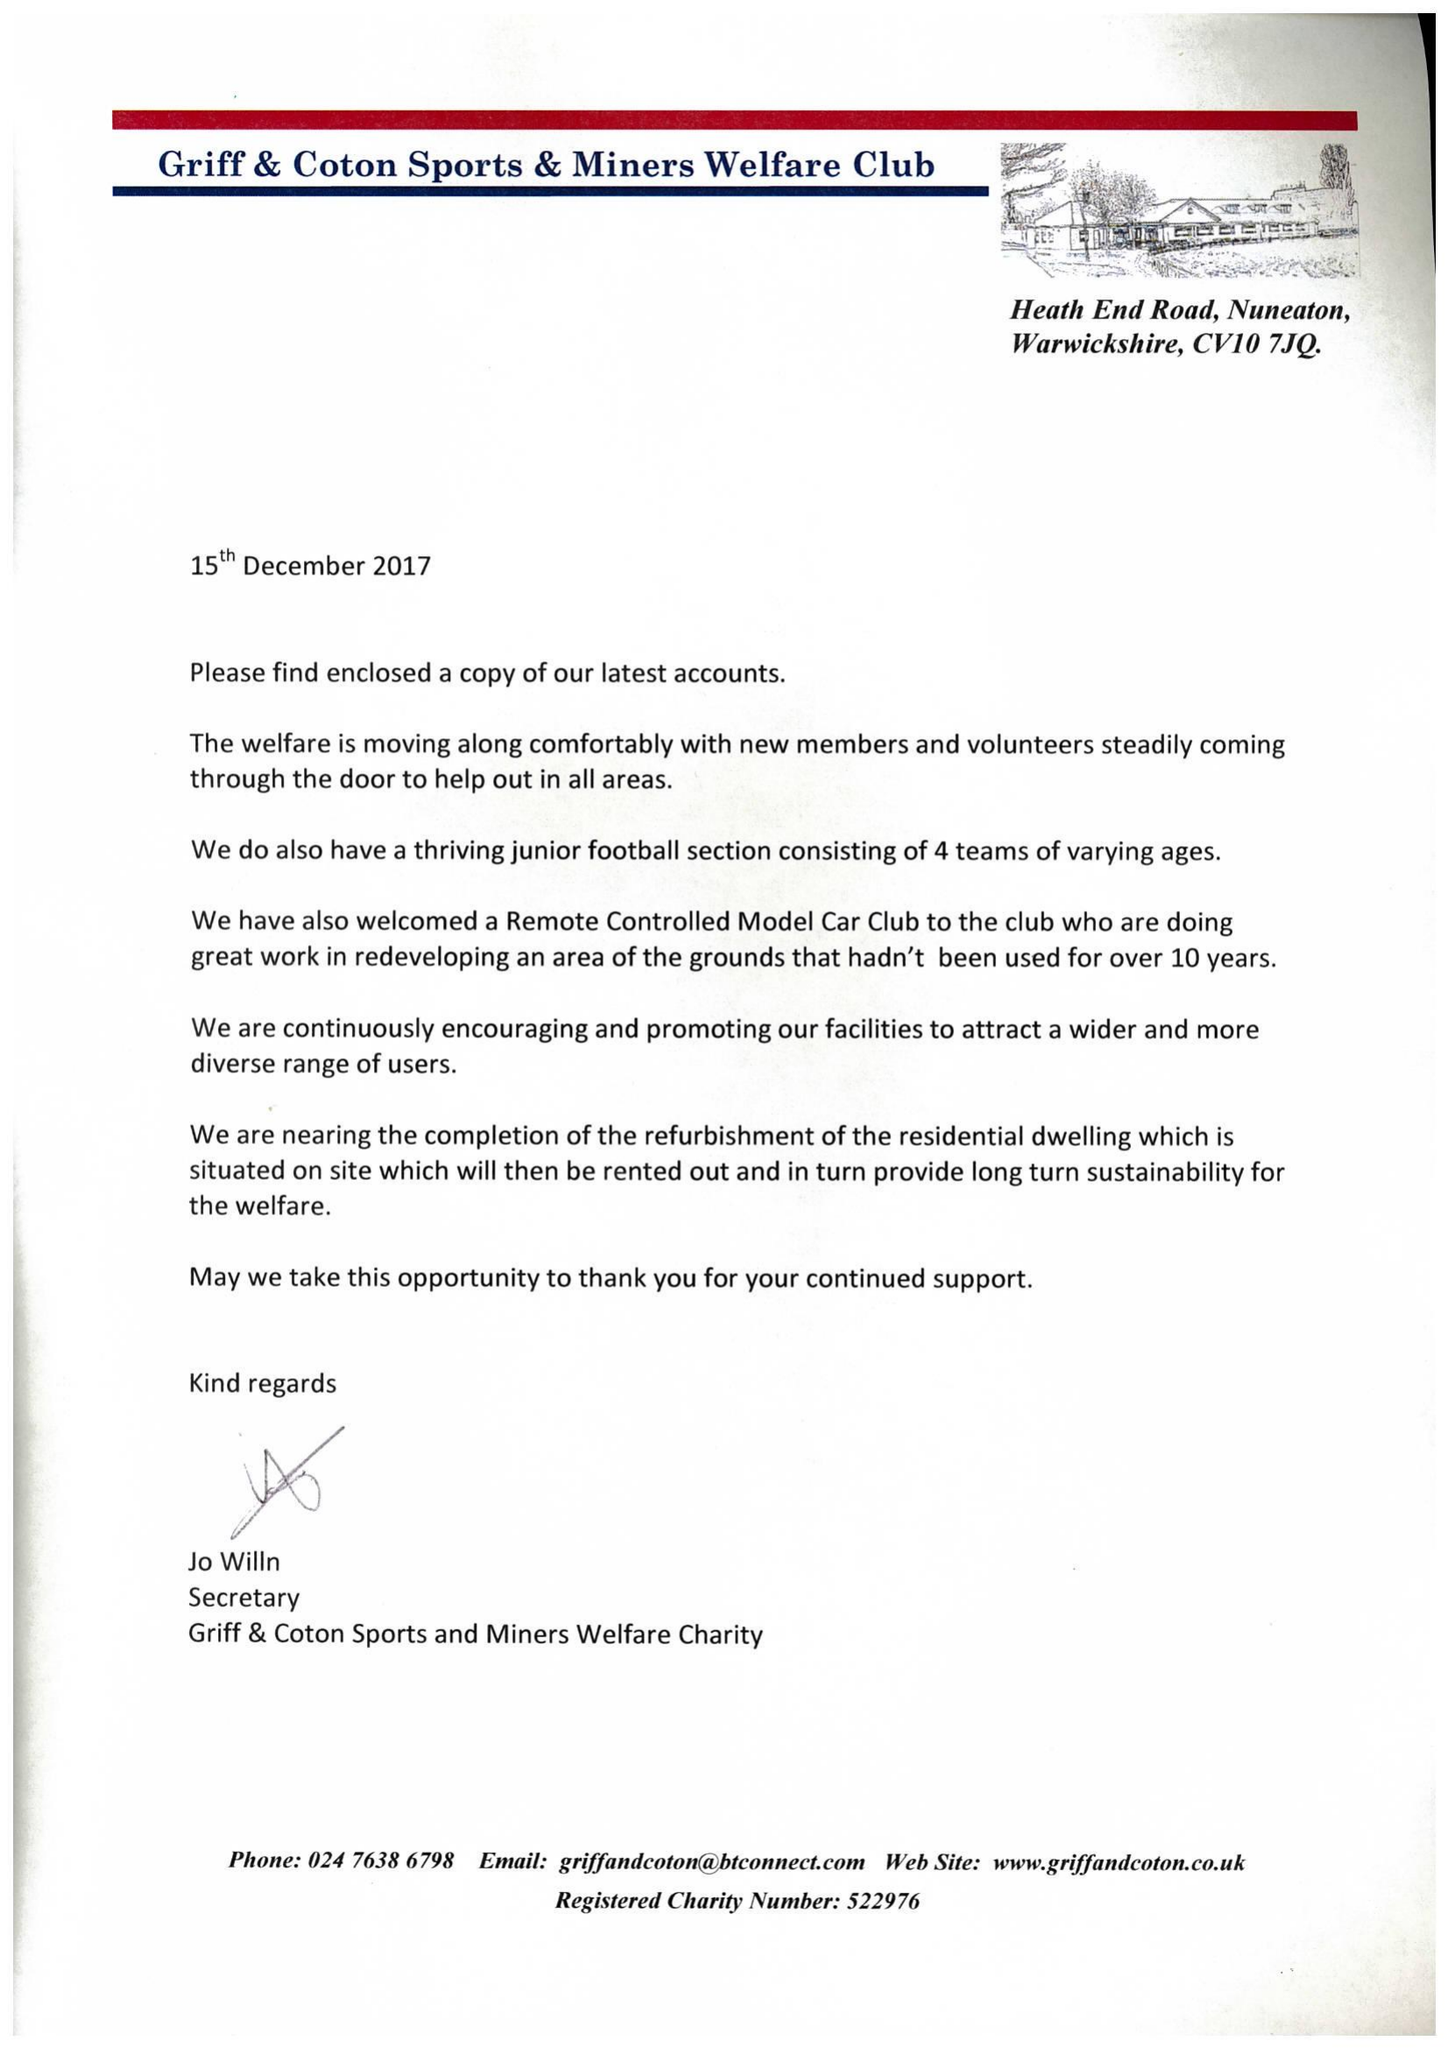What is the value for the address__post_town?
Answer the question using a single word or phrase. NUNEATON 